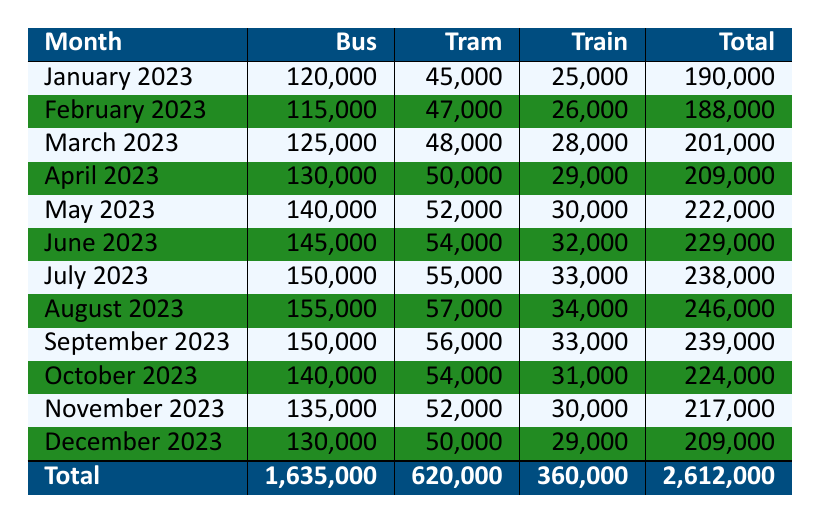What was the total ridership in July 2023? The total ridership for July 2023 is listed in the table as 238,000.
Answer: 238,000 Which month had the highest tram ridership? By comparing the tram ridership values in the table, August 2023 has the highest tram ridership at 57,000.
Answer: August 2023 What is the average bus ridership over the year? The bus ridership for the year is: 120,000 + 115,000 + 125,000 + 130,000 + 140,000 + 145,000 + 150,000 + 155,000 + 150,000 + 140,000 + 135,000 + 130,000 = 1,635,000. There are 12 months, so the average is 1,635,000 / 12 = 136,250.
Answer: 136,250 Was the total ridership in December higher than in January? In the table, December 2023 has a total ridership of 209,000, while January 2023 has a total of 190,000. Since 209,000 is greater than 190,000, the statement is true.
Answer: Yes How much did bus ridership change from January to August? The bus ridership in January was 120,000 and in August was 155,000. The change can be calculated as 155,000 - 120,000 = 35,000.
Answer: 35,000 What percentage of total ridership in June 2023 was from bus riders? The total ridership in June 2023 is 229,000 and the bus ridership is 145,000. The percentage is (145,000 / 229,000) * 100, which is approximately 63.34%.
Answer: 63.34% What was the total ridership between the months with the lowest and highest totals? The lowest total ridership is January 2023 with 190,000 and the highest is August 2023 with 246,000. The total are 190,000 + 246,000 = 436,000.
Answer: 436,000 In which month did train ridership peak, and what was that value? By reviewing the table, train ridership peaked in August 2023 at 34,000.
Answer: August 2023, 34,000 Did more people use the tram or train in September 2023? In September 2023, tram ridership was 56,000 and train ridership was 33,000. Since 56,000 is greater than 33,000, more people used the tram.
Answer: Tram What is the total difference in ridership between May and November? The total ridership in May 2023 was 222,000 and in November 2023 it was 217,000. The difference is 222,000 - 217,000 = 5,000.
Answer: 5,000 